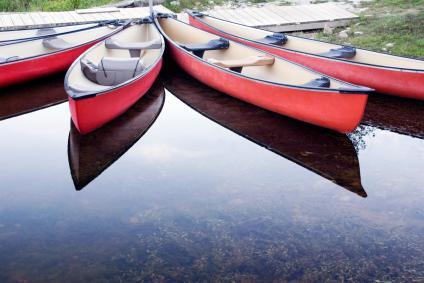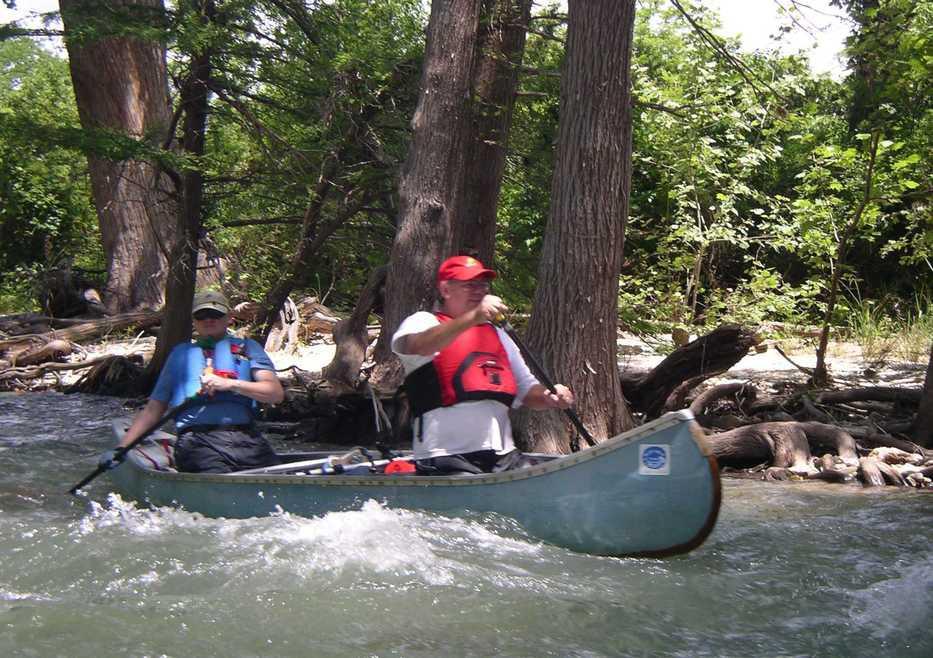The first image is the image on the left, the second image is the image on the right. For the images shown, is this caption "A group of people are in canoes with their hands in the air." true? Answer yes or no. No. 